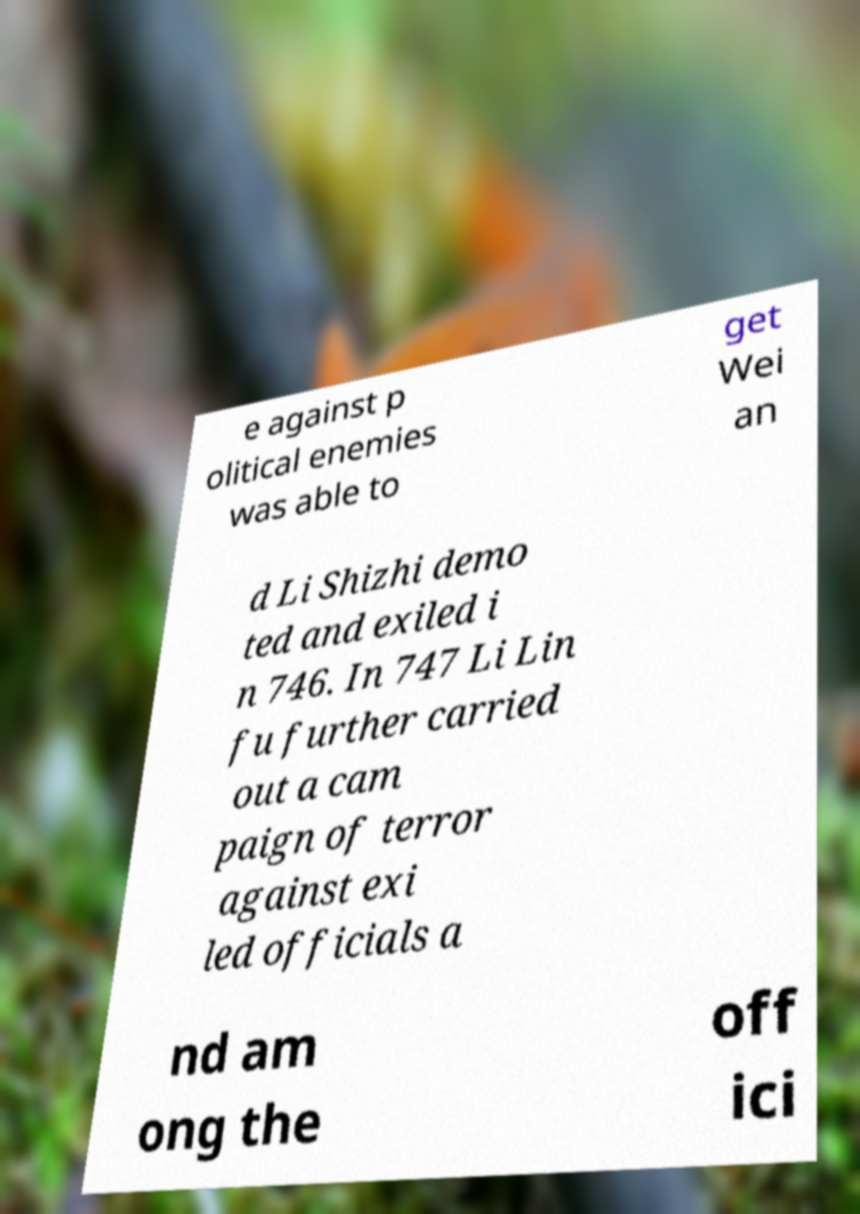For documentation purposes, I need the text within this image transcribed. Could you provide that? e against p olitical enemies was able to get Wei an d Li Shizhi demo ted and exiled i n 746. In 747 Li Lin fu further carried out a cam paign of terror against exi led officials a nd am ong the off ici 